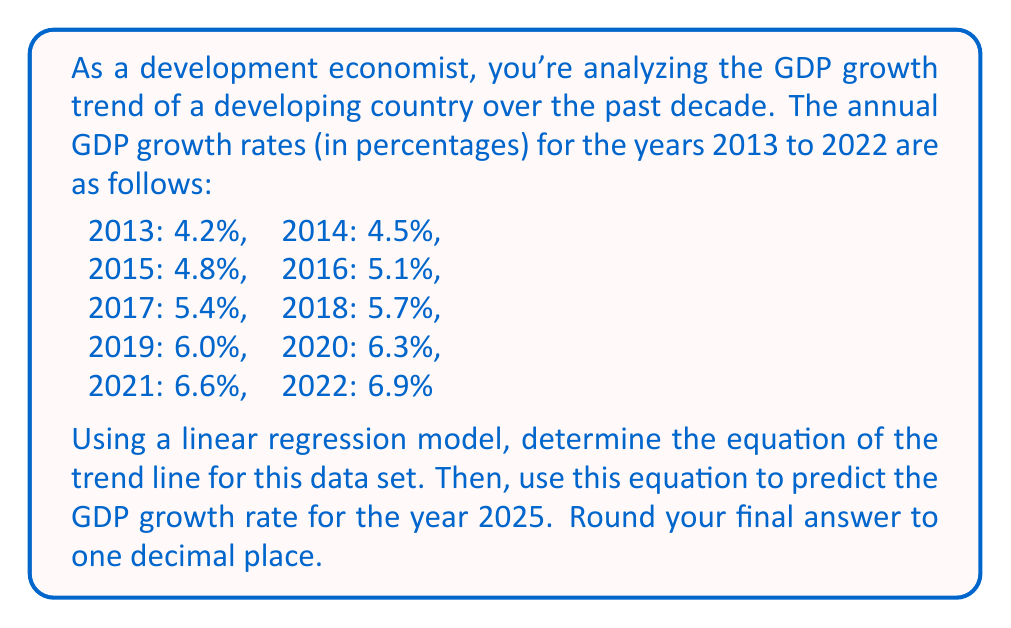What is the answer to this math problem? To solve this problem, we'll follow these steps:

1) First, we need to set up our data for linear regression. Let's assign x-values to each year, with 2013 as x = 1, 2014 as x = 2, and so on.

2) We'll use the following formulas for linear regression:
   
   Slope (m): $m = \frac{n\sum xy - \sum x \sum y}{n\sum x^2 - (\sum x)^2}$
   
   y-intercept (b): $b = \frac{\sum y - m\sum x}{n}$

   Where n is the number of data points.

3) Let's calculate the necessary sums:

   $\sum x = 55$ (sum of numbers 1 to 10)
   $\sum y = 55.5$ (sum of all growth rates)
   $\sum xy = 368.4$
   $\sum x^2 = 385$
   $n = 10$

4) Now we can calculate the slope:

   $m = \frac{10(368.4) - 55(55.5)}{10(385) - 55^2} = 0.3$

5) And the y-intercept:

   $b = \frac{55.5 - 0.3(55)}{10} = 3.9$

6) Our trend line equation is therefore:

   $y = 0.3x + 3.9$

7) To predict the GDP growth rate for 2025, we need to use x = 13 (as 2025 is 13 years after our starting year of 2013):

   $y = 0.3(13) + 3.9 = 7.8$

Therefore, the predicted GDP growth rate for 2025 is 7.8%.
Answer: 7.8% 